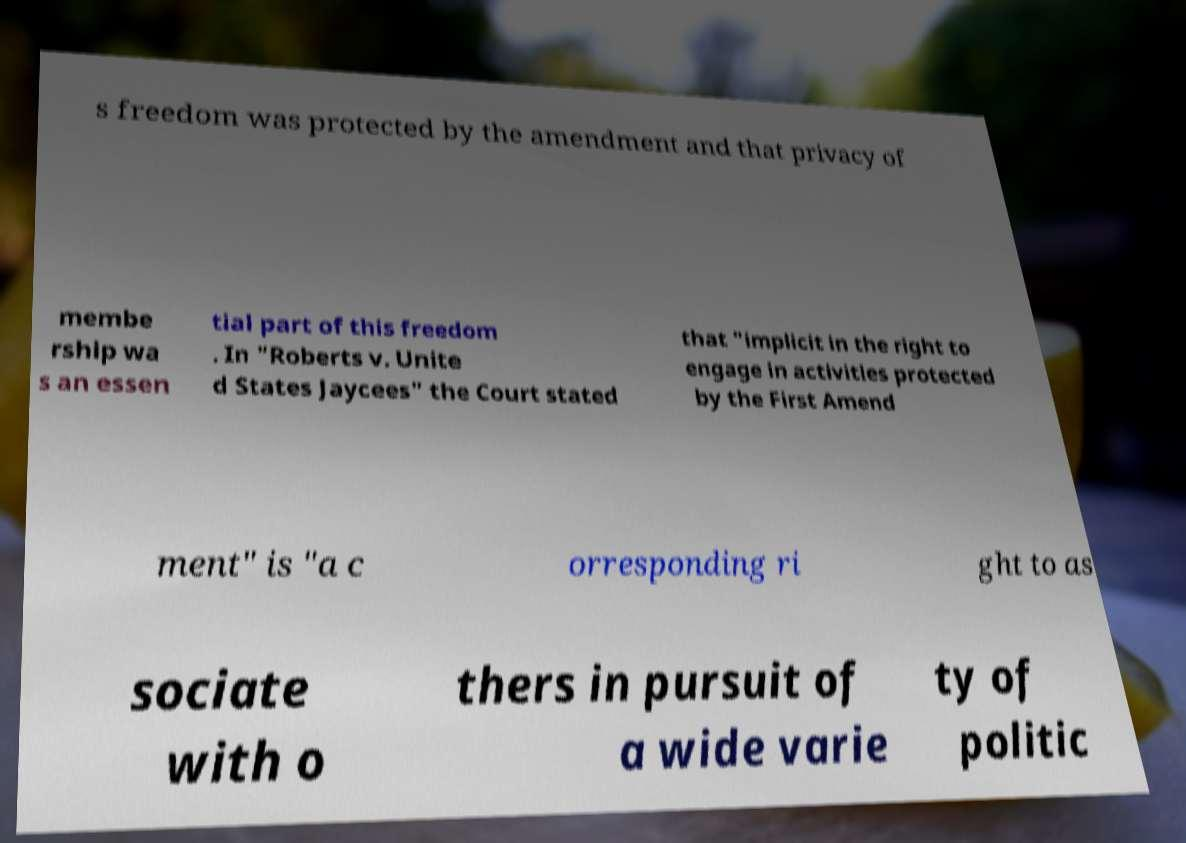Could you extract and type out the text from this image? s freedom was protected by the amendment and that privacy of membe rship wa s an essen tial part of this freedom . In "Roberts v. Unite d States Jaycees" the Court stated that "implicit in the right to engage in activities protected by the First Amend ment" is "a c orresponding ri ght to as sociate with o thers in pursuit of a wide varie ty of politic 